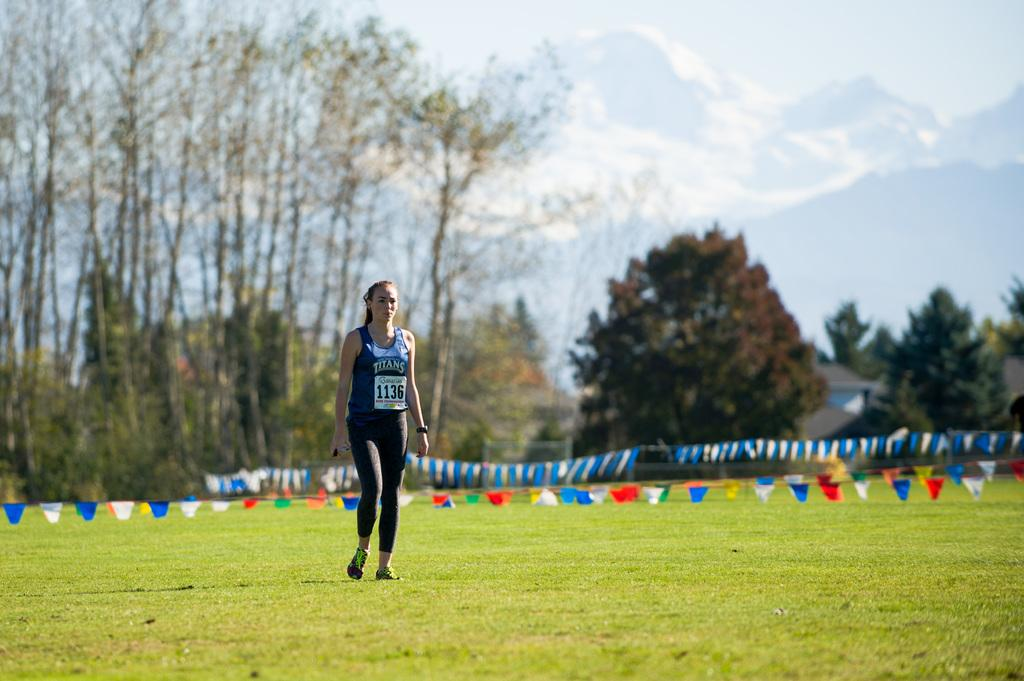<image>
Create a compact narrative representing the image presented. A lady is standing on a field wearing a tank top that says Titan. 